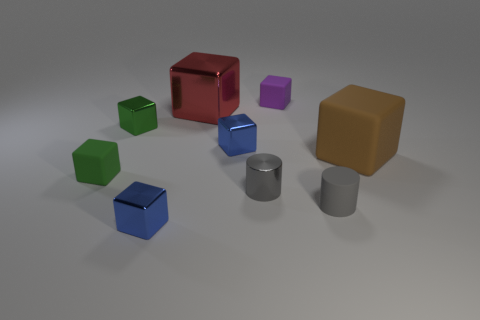Subtract all brown blocks. How many blocks are left? 6 Subtract all green cylinders. How many blue blocks are left? 2 Subtract all purple blocks. How many blocks are left? 6 Subtract 5 blocks. How many blocks are left? 2 Subtract 0 gray spheres. How many objects are left? 9 Subtract all cylinders. How many objects are left? 7 Subtract all purple cubes. Subtract all yellow spheres. How many cubes are left? 6 Subtract all big red metal spheres. Subtract all gray matte cylinders. How many objects are left? 8 Add 7 brown blocks. How many brown blocks are left? 8 Add 8 green metallic cylinders. How many green metallic cylinders exist? 8 